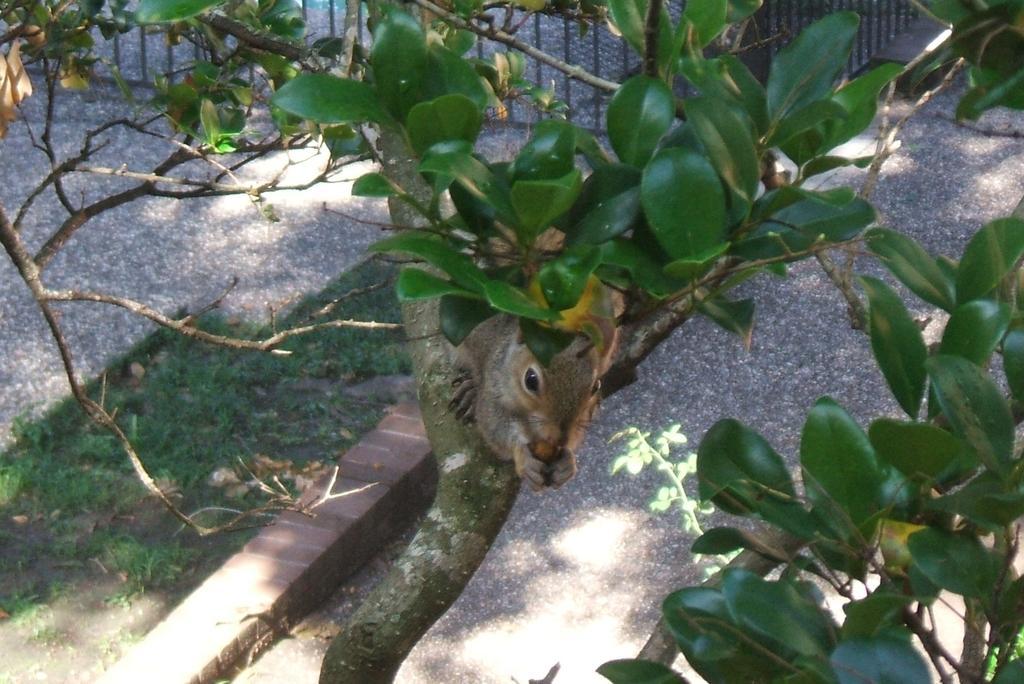Please provide a concise description of this image. Here there is an animal on the tree, where there is grass. 